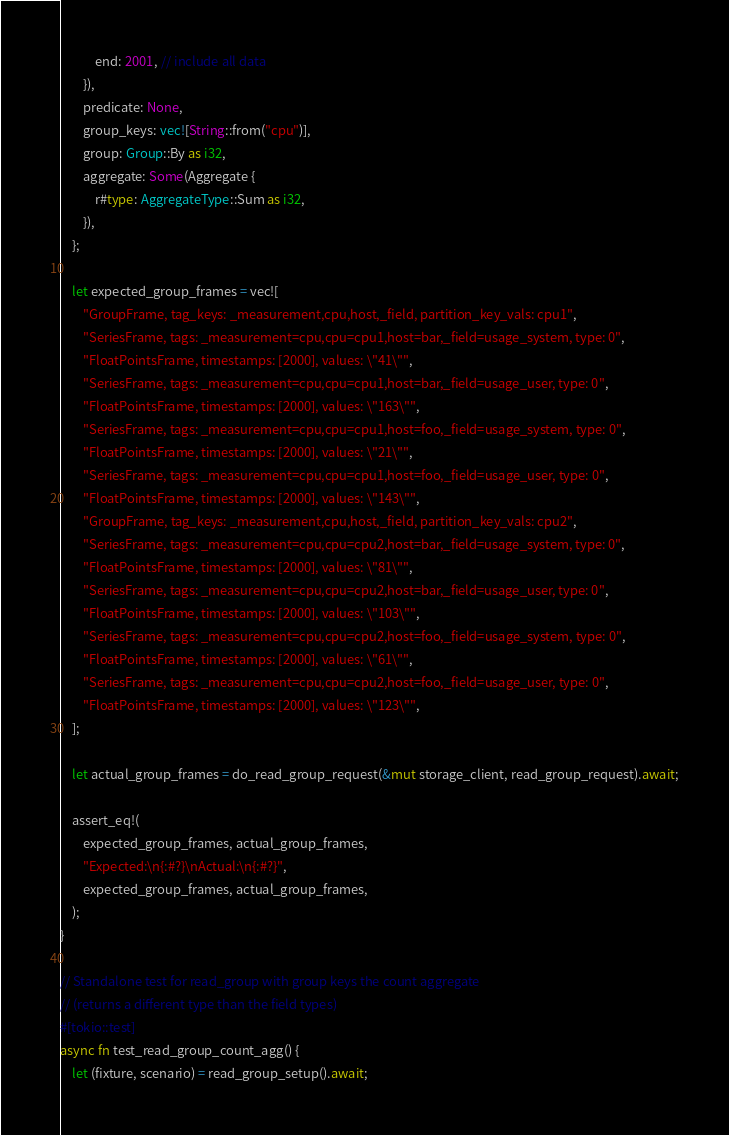Convert code to text. <code><loc_0><loc_0><loc_500><loc_500><_Rust_>            end: 2001, // include all data
        }),
        predicate: None,
        group_keys: vec![String::from("cpu")],
        group: Group::By as i32,
        aggregate: Some(Aggregate {
            r#type: AggregateType::Sum as i32,
        }),
    };

    let expected_group_frames = vec![
        "GroupFrame, tag_keys: _measurement,cpu,host,_field, partition_key_vals: cpu1",
        "SeriesFrame, tags: _measurement=cpu,cpu=cpu1,host=bar,_field=usage_system, type: 0",
        "FloatPointsFrame, timestamps: [2000], values: \"41\"",
        "SeriesFrame, tags: _measurement=cpu,cpu=cpu1,host=bar,_field=usage_user, type: 0",
        "FloatPointsFrame, timestamps: [2000], values: \"163\"",
        "SeriesFrame, tags: _measurement=cpu,cpu=cpu1,host=foo,_field=usage_system, type: 0",
        "FloatPointsFrame, timestamps: [2000], values: \"21\"",
        "SeriesFrame, tags: _measurement=cpu,cpu=cpu1,host=foo,_field=usage_user, type: 0",
        "FloatPointsFrame, timestamps: [2000], values: \"143\"",
        "GroupFrame, tag_keys: _measurement,cpu,host,_field, partition_key_vals: cpu2",
        "SeriesFrame, tags: _measurement=cpu,cpu=cpu2,host=bar,_field=usage_system, type: 0",
        "FloatPointsFrame, timestamps: [2000], values: \"81\"",
        "SeriesFrame, tags: _measurement=cpu,cpu=cpu2,host=bar,_field=usage_user, type: 0",
        "FloatPointsFrame, timestamps: [2000], values: \"103\"",
        "SeriesFrame, tags: _measurement=cpu,cpu=cpu2,host=foo,_field=usage_system, type: 0",
        "FloatPointsFrame, timestamps: [2000], values: \"61\"",
        "SeriesFrame, tags: _measurement=cpu,cpu=cpu2,host=foo,_field=usage_user, type: 0",
        "FloatPointsFrame, timestamps: [2000], values: \"123\"",
    ];

    let actual_group_frames = do_read_group_request(&mut storage_client, read_group_request).await;

    assert_eq!(
        expected_group_frames, actual_group_frames,
        "Expected:\n{:#?}\nActual:\n{:#?}",
        expected_group_frames, actual_group_frames,
    );
}

// Standalone test for read_group with group keys the count aggregate
// (returns a different type than the field types)
#[tokio::test]
async fn test_read_group_count_agg() {
    let (fixture, scenario) = read_group_setup().await;</code> 